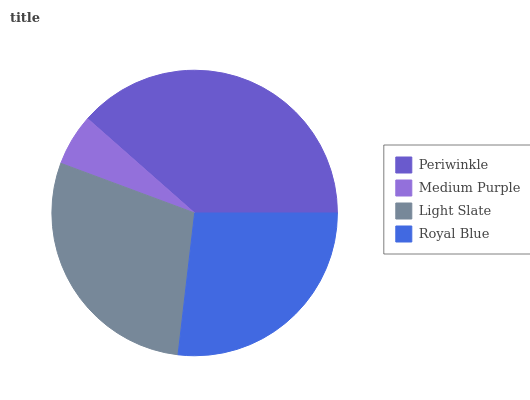Is Medium Purple the minimum?
Answer yes or no. Yes. Is Periwinkle the maximum?
Answer yes or no. Yes. Is Light Slate the minimum?
Answer yes or no. No. Is Light Slate the maximum?
Answer yes or no. No. Is Light Slate greater than Medium Purple?
Answer yes or no. Yes. Is Medium Purple less than Light Slate?
Answer yes or no. Yes. Is Medium Purple greater than Light Slate?
Answer yes or no. No. Is Light Slate less than Medium Purple?
Answer yes or no. No. Is Light Slate the high median?
Answer yes or no. Yes. Is Royal Blue the low median?
Answer yes or no. Yes. Is Medium Purple the high median?
Answer yes or no. No. Is Light Slate the low median?
Answer yes or no. No. 